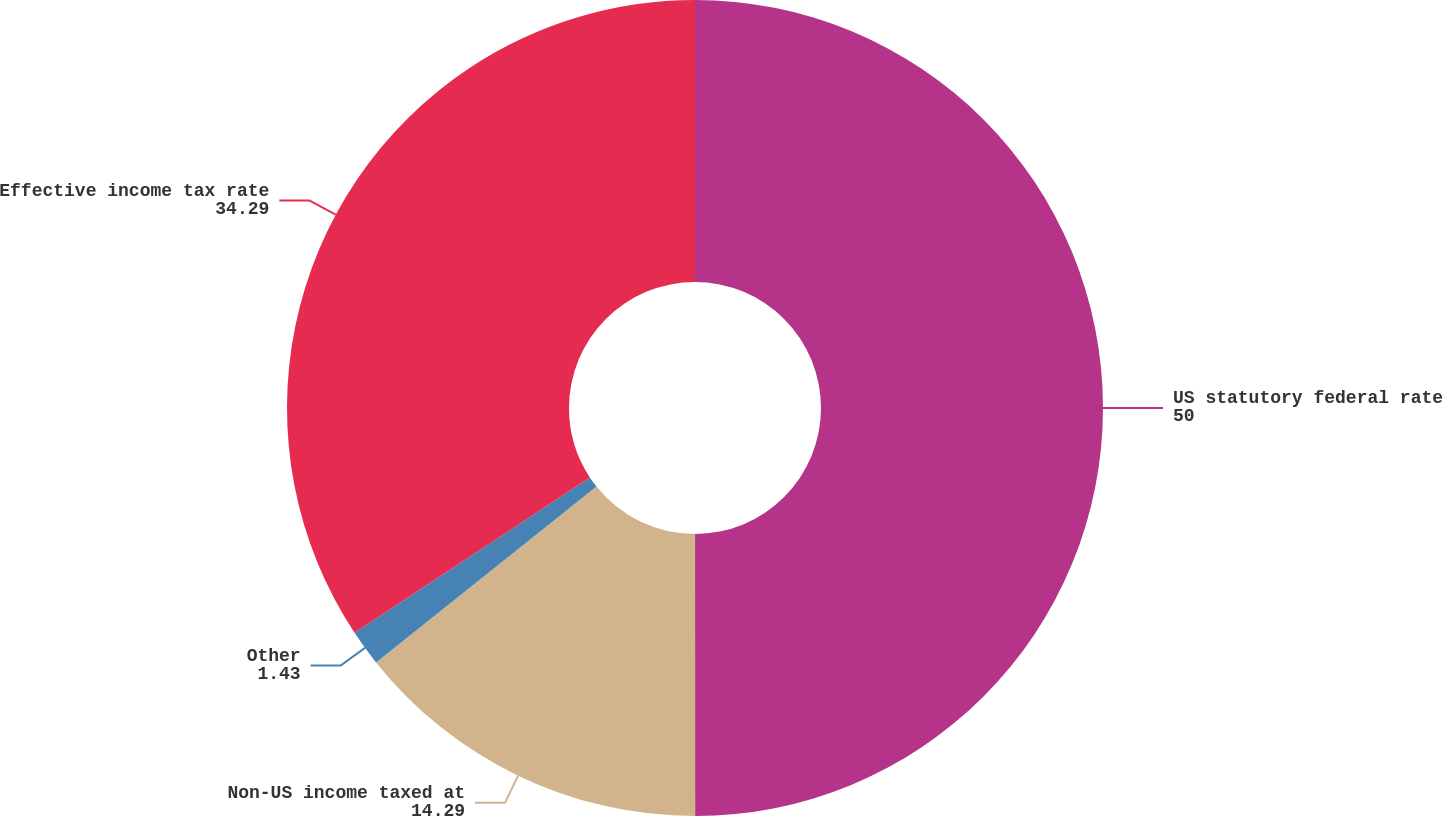<chart> <loc_0><loc_0><loc_500><loc_500><pie_chart><fcel>US statutory federal rate<fcel>Non-US income taxed at<fcel>Other<fcel>Effective income tax rate<nl><fcel>50.0%<fcel>14.29%<fcel>1.43%<fcel>34.29%<nl></chart> 